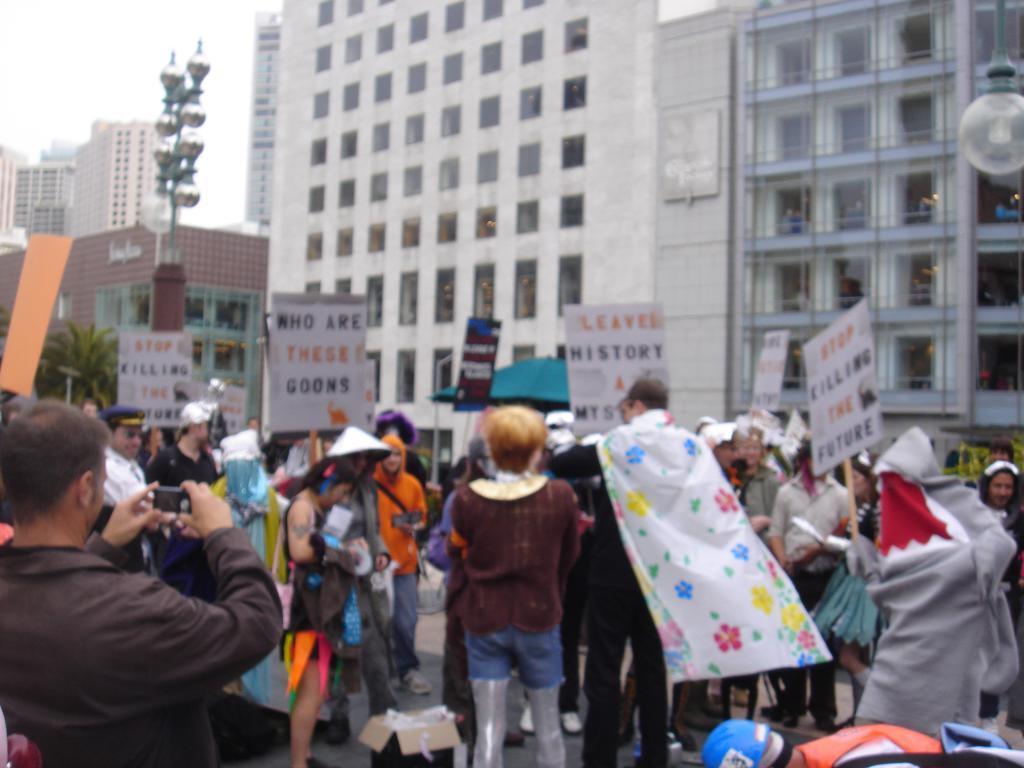How would you summarize this image in a sentence or two? In this picture there are people and we can see cardboard box, boards, lights, pole and objects. In the background of the image we can see buildings, tree and sky. 